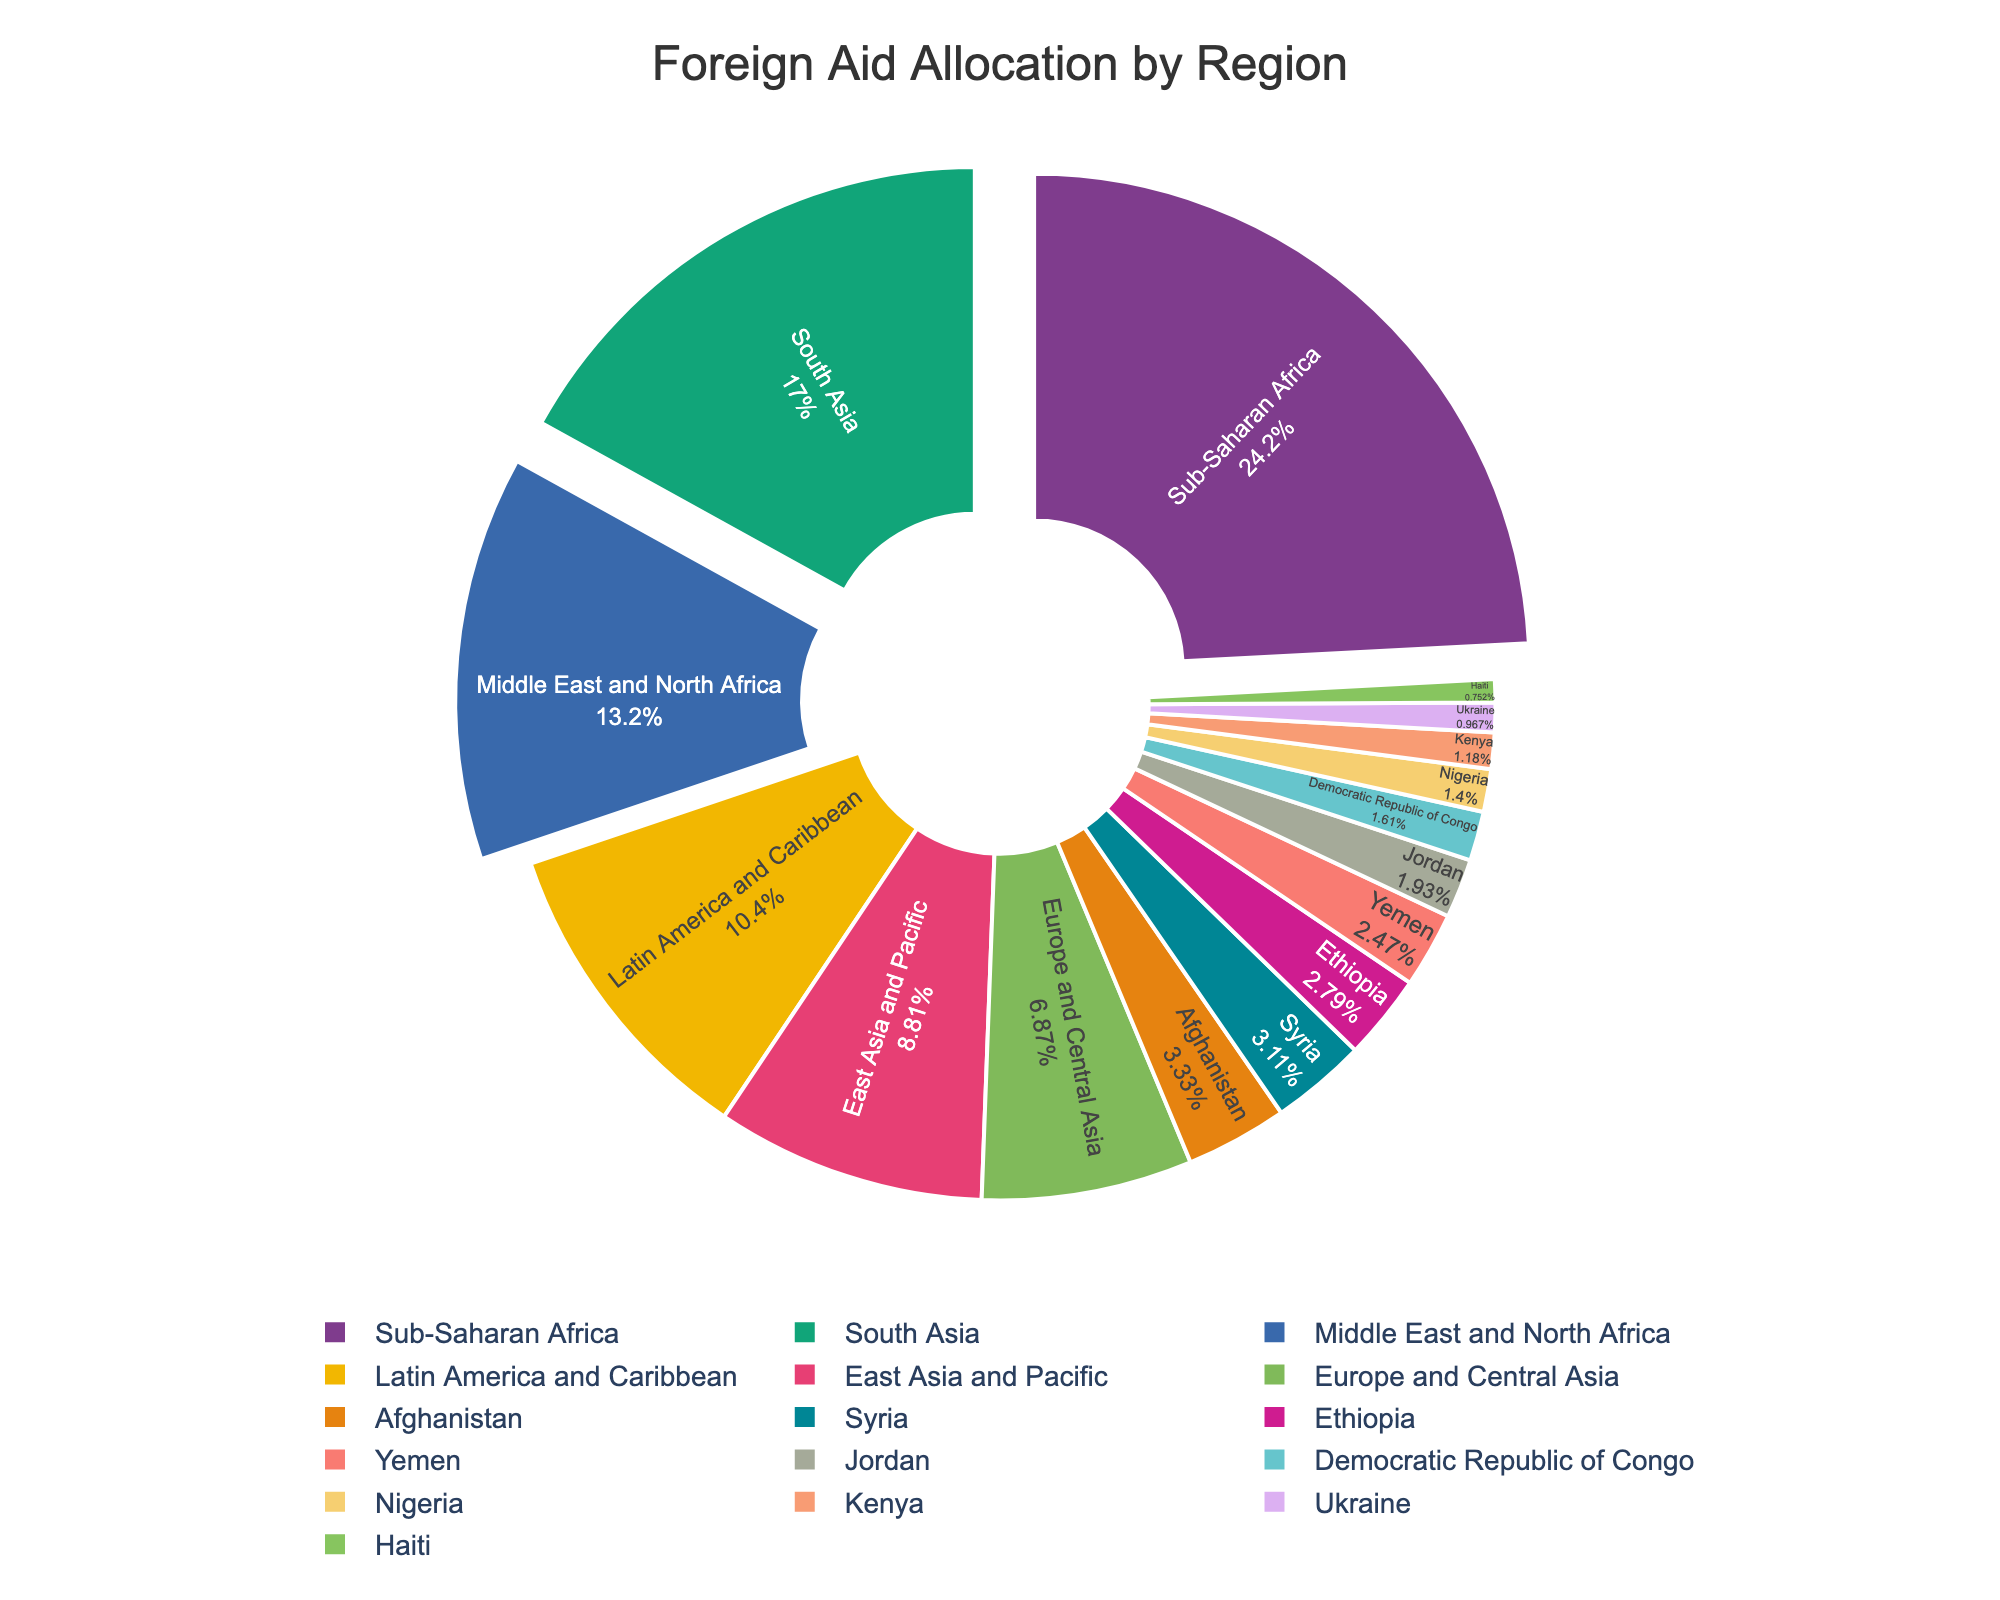What region receives the highest amount of foreign aid? The pie chart shows that Sub-Saharan Africa has the largest section, indicating it receives the highest amount of foreign aid.
Answer: Sub-Saharan Africa Which region receives more foreign aid, South Asia or the Middle East and North Africa? By comparing the size of the sections in the pie chart, South Asia has a larger section than the Middle East and North Africa.
Answer: South Asia How much more foreign aid does Latin America and Caribbean receive compared to Ukraine? Latin America and Caribbean receives 9.7 billion USD while Ukraine receives 0.9 billion USD, so the difference is 9.7 - 0.9 = 8.8 billion USD.
Answer: 8.8 billion USD What percentage of foreign aid does Sub-Saharan Africa receive? Sub-Saharan Africa's allocation, represented in the pie chart, can be seen as the largest slice, pulling slightly out for emphasis. The text inside the slice shows the exact percentage.
Answer: (Percentage value shown in the chart) Which regions combined receive a total of over 38 billion USD? Sub-Saharan Africa receives 22.5 billion USD, and South Asia receives 15.8 billion USD. Adding these two gives 22.5 + 15.8 = 38.3 billion USD.
Answer: Sub-Saharan Africa and South Asia Does Europe and Central Asia receive more or less aid than East Asia and Pacific? By looking at the pie chart sections, Europe and Central Asia receive less aid than East Asia and Pacific.
Answer: Less What is the total foreign aid allocated to Afghanistan and Syria? Afghanistan receives 3.1 billion USD, and Syria receives 2.9 billion USD. Summing them gives 3.1 + 2.9 = 6.0 billion USD.
Answer: 6.0 billion USD Which region has a smaller allocation, Haiti or Kenya? The pie chart shows that Haiti's section is smaller than Kenya's, indicating that Haiti receives a smaller allocation.
Answer: Haiti How does the foreign aid to Yemen compare to that of Ethiopia and Jordan combined? Yemen receives 2.3 billion USD. Ethiopia receives 2.6 billion USD and Jordan 1.8 billion USD. Combined, Ethiopia and Jordan receive 2.6 + 1.8 = 4.4 billion USD, which is greater than Yemen's 2.3 billion USD.
Answer: Less Which individual country receives the highest amount of foreign aid? The pie chart shows the largest individual slice among the specific countries, which is Afghanistan.
Answer: Afghanistan 